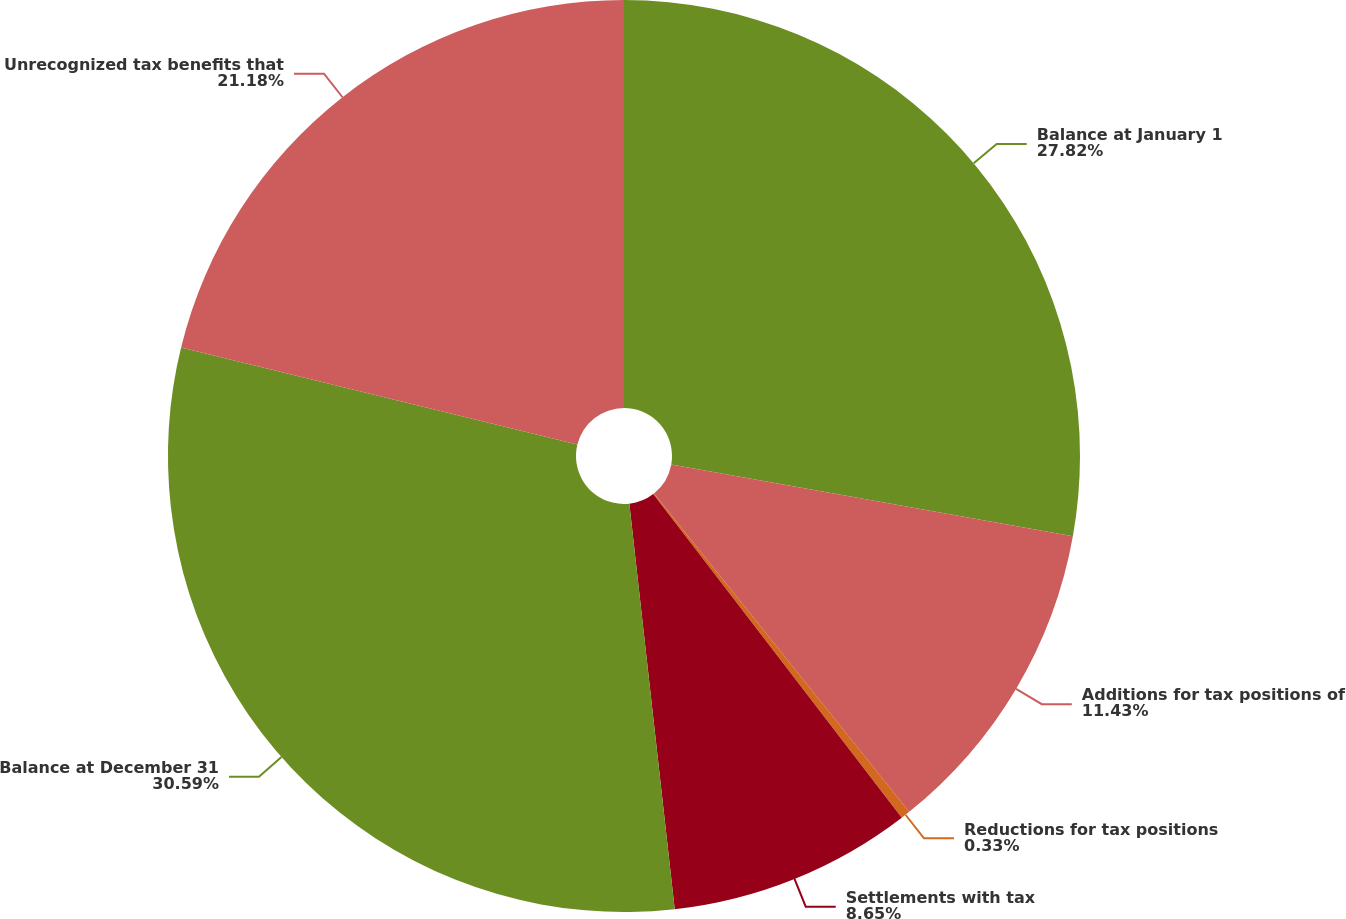Convert chart to OTSL. <chart><loc_0><loc_0><loc_500><loc_500><pie_chart><fcel>Balance at January 1<fcel>Additions for tax positions of<fcel>Reductions for tax positions<fcel>Settlements with tax<fcel>Balance at December 31<fcel>Unrecognized tax benefits that<nl><fcel>27.82%<fcel>11.43%<fcel>0.33%<fcel>8.65%<fcel>30.6%<fcel>21.18%<nl></chart> 